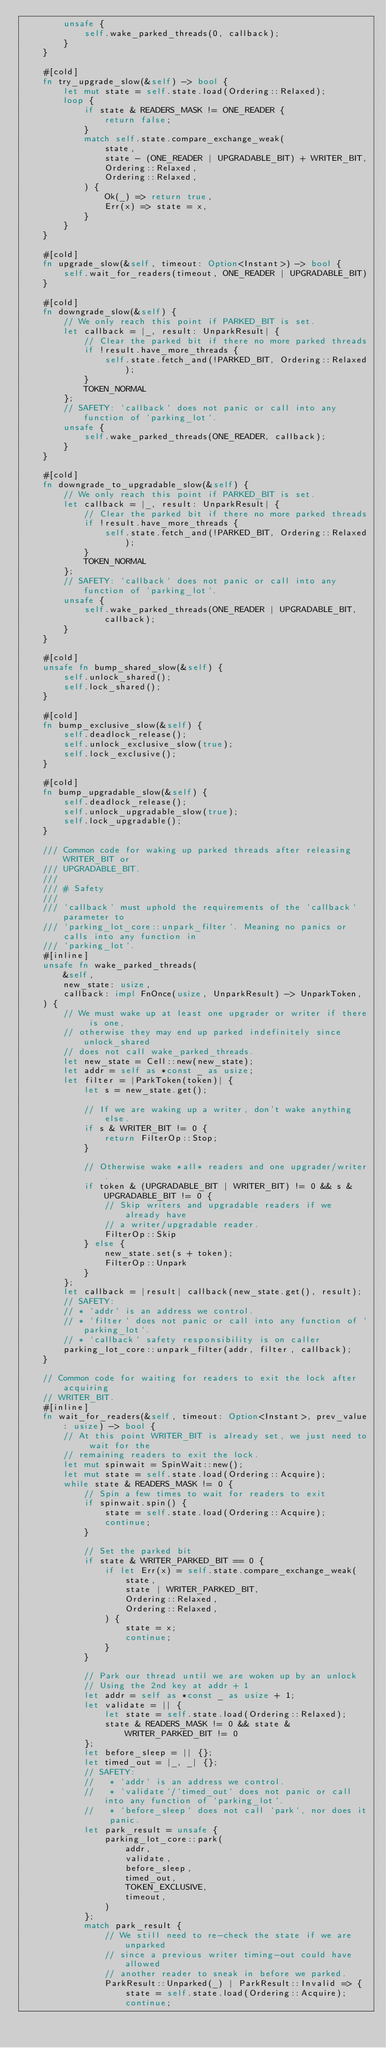Convert code to text. <code><loc_0><loc_0><loc_500><loc_500><_Rust_>        unsafe {
            self.wake_parked_threads(0, callback);
        }
    }

    #[cold]
    fn try_upgrade_slow(&self) -> bool {
        let mut state = self.state.load(Ordering::Relaxed);
        loop {
            if state & READERS_MASK != ONE_READER {
                return false;
            }
            match self.state.compare_exchange_weak(
                state,
                state - (ONE_READER | UPGRADABLE_BIT) + WRITER_BIT,
                Ordering::Relaxed,
                Ordering::Relaxed,
            ) {
                Ok(_) => return true,
                Err(x) => state = x,
            }
        }
    }

    #[cold]
    fn upgrade_slow(&self, timeout: Option<Instant>) -> bool {
        self.wait_for_readers(timeout, ONE_READER | UPGRADABLE_BIT)
    }

    #[cold]
    fn downgrade_slow(&self) {
        // We only reach this point if PARKED_BIT is set.
        let callback = |_, result: UnparkResult| {
            // Clear the parked bit if there no more parked threads
            if !result.have_more_threads {
                self.state.fetch_and(!PARKED_BIT, Ordering::Relaxed);
            }
            TOKEN_NORMAL
        };
        // SAFETY: `callback` does not panic or call into any function of `parking_lot`.
        unsafe {
            self.wake_parked_threads(ONE_READER, callback);
        }
    }

    #[cold]
    fn downgrade_to_upgradable_slow(&self) {
        // We only reach this point if PARKED_BIT is set.
        let callback = |_, result: UnparkResult| {
            // Clear the parked bit if there no more parked threads
            if !result.have_more_threads {
                self.state.fetch_and(!PARKED_BIT, Ordering::Relaxed);
            }
            TOKEN_NORMAL
        };
        // SAFETY: `callback` does not panic or call into any function of `parking_lot`.
        unsafe {
            self.wake_parked_threads(ONE_READER | UPGRADABLE_BIT, callback);
        }
    }

    #[cold]
    unsafe fn bump_shared_slow(&self) {
        self.unlock_shared();
        self.lock_shared();
    }

    #[cold]
    fn bump_exclusive_slow(&self) {
        self.deadlock_release();
        self.unlock_exclusive_slow(true);
        self.lock_exclusive();
    }

    #[cold]
    fn bump_upgradable_slow(&self) {
        self.deadlock_release();
        self.unlock_upgradable_slow(true);
        self.lock_upgradable();
    }

    /// Common code for waking up parked threads after releasing WRITER_BIT or
    /// UPGRADABLE_BIT.
    ///
    /// # Safety
    ///
    /// `callback` must uphold the requirements of the `callback` parameter to
    /// `parking_lot_core::unpark_filter`. Meaning no panics or calls into any function in
    /// `parking_lot`.
    #[inline]
    unsafe fn wake_parked_threads(
        &self,
        new_state: usize,
        callback: impl FnOnce(usize, UnparkResult) -> UnparkToken,
    ) {
        // We must wake up at least one upgrader or writer if there is one,
        // otherwise they may end up parked indefinitely since unlock_shared
        // does not call wake_parked_threads.
        let new_state = Cell::new(new_state);
        let addr = self as *const _ as usize;
        let filter = |ParkToken(token)| {
            let s = new_state.get();

            // If we are waking up a writer, don't wake anything else.
            if s & WRITER_BIT != 0 {
                return FilterOp::Stop;
            }

            // Otherwise wake *all* readers and one upgrader/writer.
            if token & (UPGRADABLE_BIT | WRITER_BIT) != 0 && s & UPGRADABLE_BIT != 0 {
                // Skip writers and upgradable readers if we already have
                // a writer/upgradable reader.
                FilterOp::Skip
            } else {
                new_state.set(s + token);
                FilterOp::Unpark
            }
        };
        let callback = |result| callback(new_state.get(), result);
        // SAFETY:
        // * `addr` is an address we control.
        // * `filter` does not panic or call into any function of `parking_lot`.
        // * `callback` safety responsibility is on caller
        parking_lot_core::unpark_filter(addr, filter, callback);
    }

    // Common code for waiting for readers to exit the lock after acquiring
    // WRITER_BIT.
    #[inline]
    fn wait_for_readers(&self, timeout: Option<Instant>, prev_value: usize) -> bool {
        // At this point WRITER_BIT is already set, we just need to wait for the
        // remaining readers to exit the lock.
        let mut spinwait = SpinWait::new();
        let mut state = self.state.load(Ordering::Acquire);
        while state & READERS_MASK != 0 {
            // Spin a few times to wait for readers to exit
            if spinwait.spin() {
                state = self.state.load(Ordering::Acquire);
                continue;
            }

            // Set the parked bit
            if state & WRITER_PARKED_BIT == 0 {
                if let Err(x) = self.state.compare_exchange_weak(
                    state,
                    state | WRITER_PARKED_BIT,
                    Ordering::Relaxed,
                    Ordering::Relaxed,
                ) {
                    state = x;
                    continue;
                }
            }

            // Park our thread until we are woken up by an unlock
            // Using the 2nd key at addr + 1
            let addr = self as *const _ as usize + 1;
            let validate = || {
                let state = self.state.load(Ordering::Relaxed);
                state & READERS_MASK != 0 && state & WRITER_PARKED_BIT != 0
            };
            let before_sleep = || {};
            let timed_out = |_, _| {};
            // SAFETY:
            //   * `addr` is an address we control.
            //   * `validate`/`timed_out` does not panic or call into any function of `parking_lot`.
            //   * `before_sleep` does not call `park`, nor does it panic.
            let park_result = unsafe {
                parking_lot_core::park(
                    addr,
                    validate,
                    before_sleep,
                    timed_out,
                    TOKEN_EXCLUSIVE,
                    timeout,
                )
            };
            match park_result {
                // We still need to re-check the state if we are unparked
                // since a previous writer timing-out could have allowed
                // another reader to sneak in before we parked.
                ParkResult::Unparked(_) | ParkResult::Invalid => {
                    state = self.state.load(Ordering::Acquire);
                    continue;</code> 